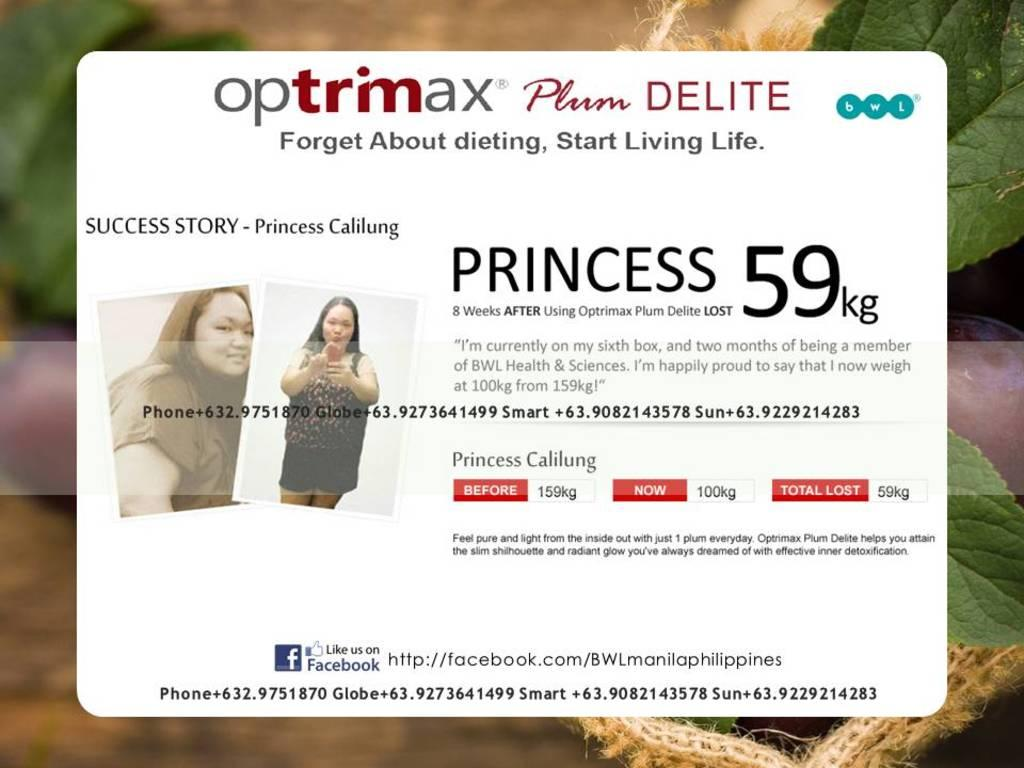What can be seen in the image that has images and writing? There are pictures in the image with writing on them. What type of vegetation is visible in the image? There are leaves visible in the image. How would you describe the background of the image? The background of the image is blurred. What type of poison is being used to create the blurred effect in the image? There is no poison present in the image; the blurred effect is likely due to the camera settings or focus. 